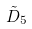<formula> <loc_0><loc_0><loc_500><loc_500>\tilde { D } _ { 5 }</formula> 